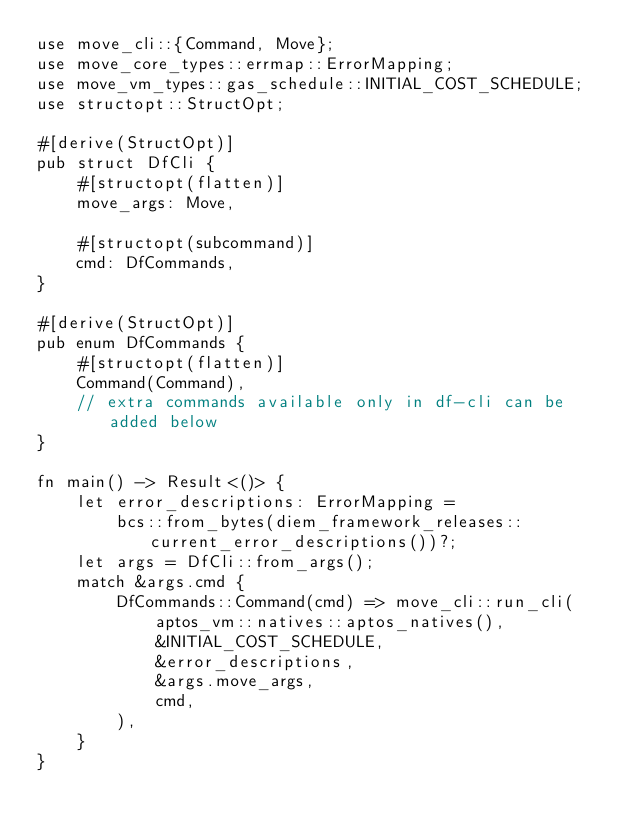<code> <loc_0><loc_0><loc_500><loc_500><_Rust_>use move_cli::{Command, Move};
use move_core_types::errmap::ErrorMapping;
use move_vm_types::gas_schedule::INITIAL_COST_SCHEDULE;
use structopt::StructOpt;

#[derive(StructOpt)]
pub struct DfCli {
    #[structopt(flatten)]
    move_args: Move,

    #[structopt(subcommand)]
    cmd: DfCommands,
}

#[derive(StructOpt)]
pub enum DfCommands {
    #[structopt(flatten)]
    Command(Command),
    // extra commands available only in df-cli can be added below
}

fn main() -> Result<()> {
    let error_descriptions: ErrorMapping =
        bcs::from_bytes(diem_framework_releases::current_error_descriptions())?;
    let args = DfCli::from_args();
    match &args.cmd {
        DfCommands::Command(cmd) => move_cli::run_cli(
            aptos_vm::natives::aptos_natives(),
            &INITIAL_COST_SCHEDULE,
            &error_descriptions,
            &args.move_args,
            cmd,
        ),
    }
}
</code> 